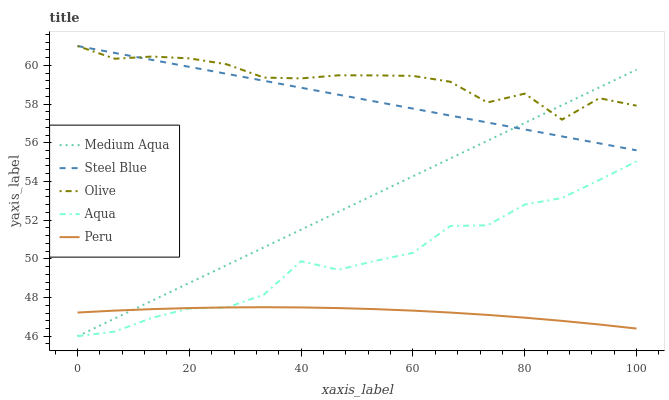Does Peru have the minimum area under the curve?
Answer yes or no. Yes. Does Olive have the maximum area under the curve?
Answer yes or no. Yes. Does Aqua have the minimum area under the curve?
Answer yes or no. No. Does Aqua have the maximum area under the curve?
Answer yes or no. No. Is Medium Aqua the smoothest?
Answer yes or no. Yes. Is Olive the roughest?
Answer yes or no. Yes. Is Aqua the smoothest?
Answer yes or no. No. Is Aqua the roughest?
Answer yes or no. No. Does Aqua have the lowest value?
Answer yes or no. Yes. Does Steel Blue have the lowest value?
Answer yes or no. No. Does Steel Blue have the highest value?
Answer yes or no. Yes. Does Aqua have the highest value?
Answer yes or no. No. Is Aqua less than Steel Blue?
Answer yes or no. Yes. Is Steel Blue greater than Peru?
Answer yes or no. Yes. Does Medium Aqua intersect Steel Blue?
Answer yes or no. Yes. Is Medium Aqua less than Steel Blue?
Answer yes or no. No. Is Medium Aqua greater than Steel Blue?
Answer yes or no. No. Does Aqua intersect Steel Blue?
Answer yes or no. No. 